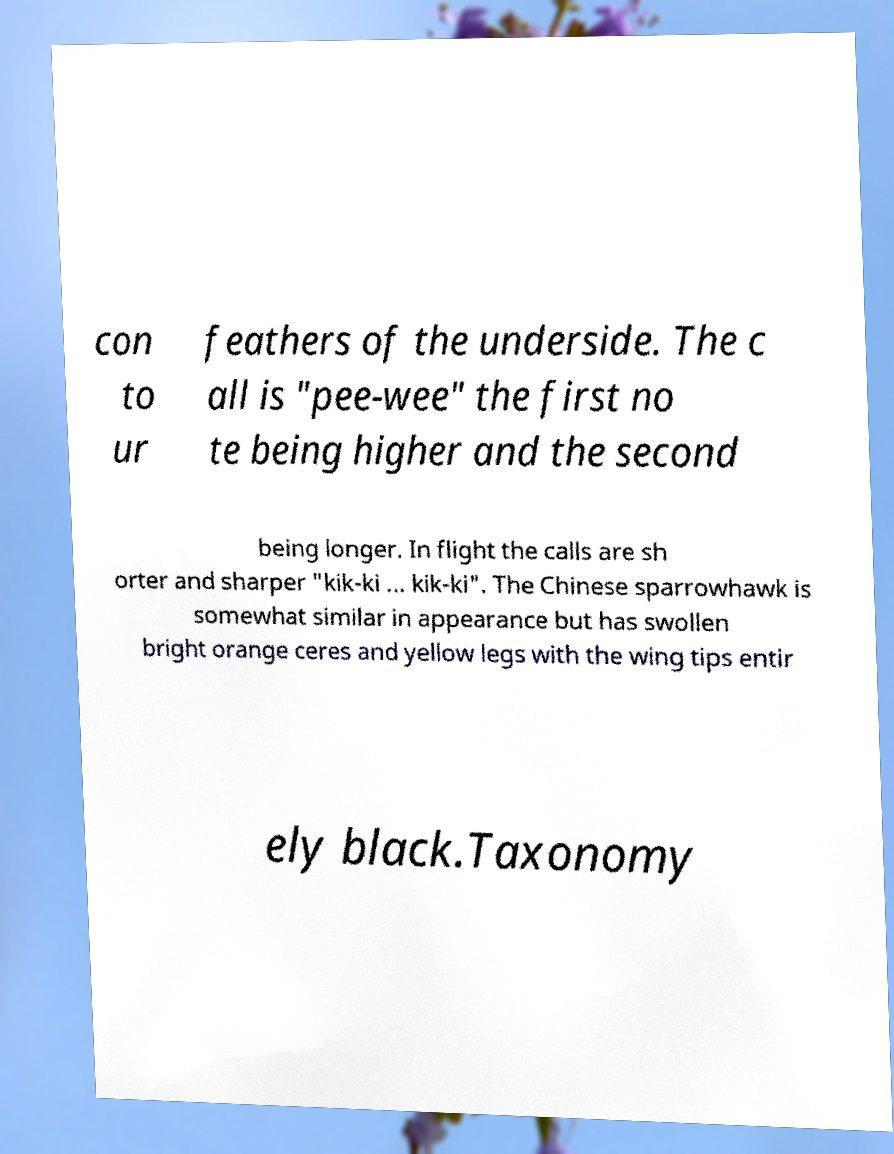There's text embedded in this image that I need extracted. Can you transcribe it verbatim? con to ur feathers of the underside. The c all is "pee-wee" the first no te being higher and the second being longer. In flight the calls are sh orter and sharper "kik-ki ... kik-ki". The Chinese sparrowhawk is somewhat similar in appearance but has swollen bright orange ceres and yellow legs with the wing tips entir ely black.Taxonomy 